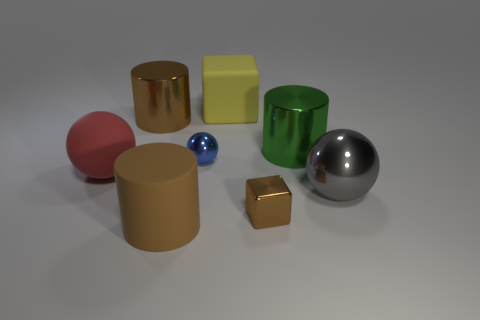Add 1 small gray rubber things. How many objects exist? 9 Subtract all balls. How many objects are left? 5 Add 2 small gray objects. How many small gray objects exist? 2 Subtract 0 blue cylinders. How many objects are left? 8 Subtract all metallic cylinders. Subtract all big metal cylinders. How many objects are left? 4 Add 2 big brown matte cylinders. How many big brown matte cylinders are left? 3 